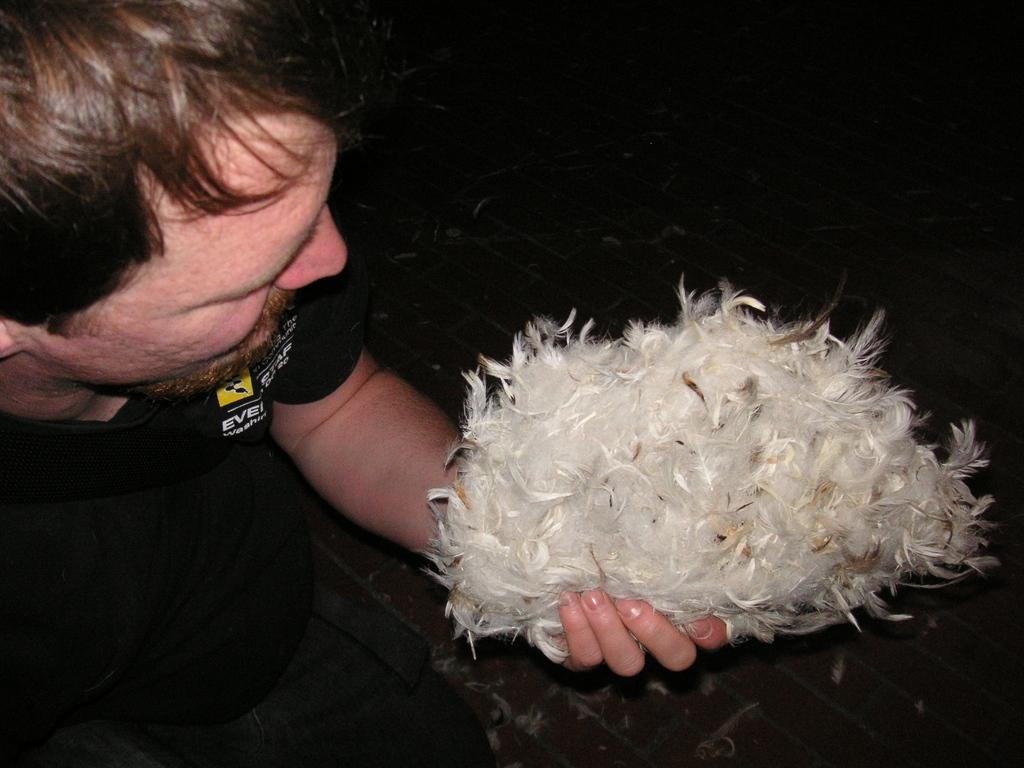What is the main subject of the image? There is a person in the image. What is the person holding in the image? The person is holding feathers. What is the person wearing in the image? The person is wearing a black t-shirt. What type of battle is taking place in the image? There is no battle present in the image; it features a person holding feathers and wearing a black t-shirt. Can you see any apples in the image? There are no apples present in the image. 